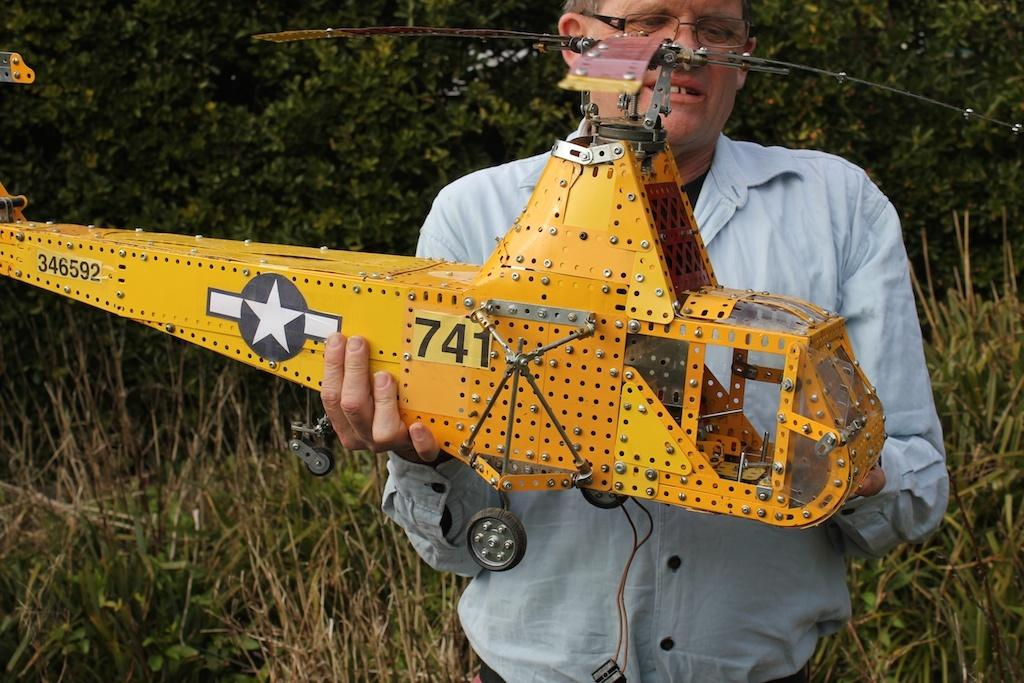What is the person in the image holding? The person is holding an artificial helicopter. What can be seen in the background of the image? There are trees visible in the background of the image. What type of vegetation is present at the bottom of the image? There are plants at the bottom of the image. What type of advice is the governor giving in the image? There is no governor present in the image, and therefore no advice can be given. 